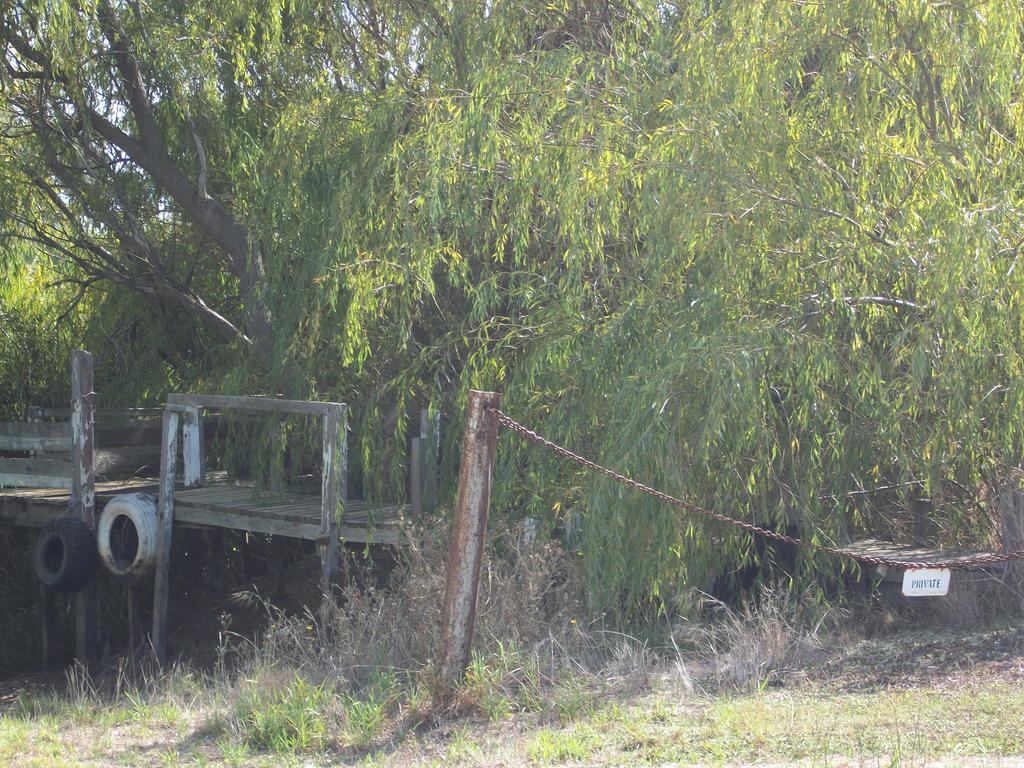What type of surface is at the bottom of the picture? There is grass at the bottom of the picture, along with an iron rod and a chain. What can be seen on the left side of the picture? There is a wooden object that resembles a bench on the left side of the picture. What is visible in the background of the picture? Trees are present in the background of the picture. What time is displayed on the clock in the picture? There is no clock present in the picture; it features grass, an iron rod, a chain, a wooden object resembling a bench, and trees in the background. 